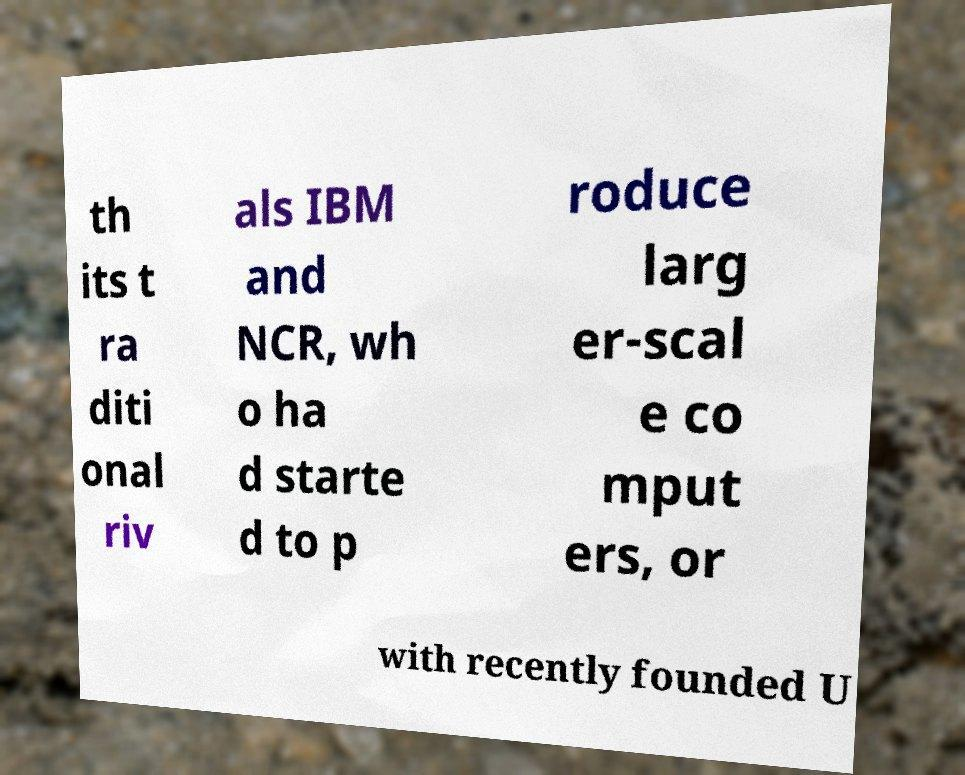What messages or text are displayed in this image? I need them in a readable, typed format. th its t ra diti onal riv als IBM and NCR, wh o ha d starte d to p roduce larg er-scal e co mput ers, or with recently founded U 